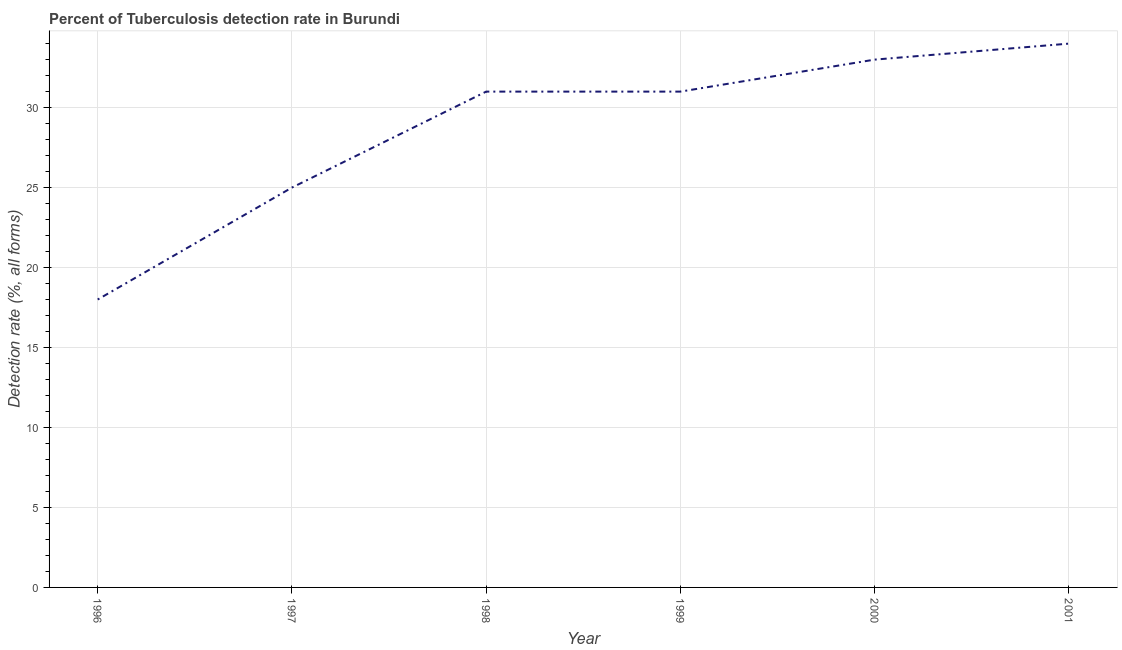What is the detection rate of tuberculosis in 2000?
Your answer should be compact. 33. Across all years, what is the maximum detection rate of tuberculosis?
Provide a succinct answer. 34. Across all years, what is the minimum detection rate of tuberculosis?
Provide a short and direct response. 18. In which year was the detection rate of tuberculosis maximum?
Provide a succinct answer. 2001. In which year was the detection rate of tuberculosis minimum?
Ensure brevity in your answer.  1996. What is the sum of the detection rate of tuberculosis?
Your answer should be compact. 172. What is the difference between the detection rate of tuberculosis in 1999 and 2001?
Your response must be concise. -3. What is the average detection rate of tuberculosis per year?
Provide a short and direct response. 28.67. What is the median detection rate of tuberculosis?
Your answer should be compact. 31. What is the ratio of the detection rate of tuberculosis in 1996 to that in 1997?
Ensure brevity in your answer.  0.72. Is the detection rate of tuberculosis in 1998 less than that in 2000?
Make the answer very short. Yes. What is the difference between the highest and the second highest detection rate of tuberculosis?
Ensure brevity in your answer.  1. Is the sum of the detection rate of tuberculosis in 1997 and 1998 greater than the maximum detection rate of tuberculosis across all years?
Make the answer very short. Yes. What is the difference between the highest and the lowest detection rate of tuberculosis?
Provide a succinct answer. 16. How many lines are there?
Ensure brevity in your answer.  1. What is the difference between two consecutive major ticks on the Y-axis?
Give a very brief answer. 5. Does the graph contain any zero values?
Your answer should be compact. No. Does the graph contain grids?
Your answer should be compact. Yes. What is the title of the graph?
Ensure brevity in your answer.  Percent of Tuberculosis detection rate in Burundi. What is the label or title of the Y-axis?
Provide a succinct answer. Detection rate (%, all forms). What is the Detection rate (%, all forms) in 1997?
Offer a very short reply. 25. What is the Detection rate (%, all forms) in 2000?
Ensure brevity in your answer.  33. What is the Detection rate (%, all forms) of 2001?
Offer a very short reply. 34. What is the difference between the Detection rate (%, all forms) in 1996 and 1999?
Keep it short and to the point. -13. What is the difference between the Detection rate (%, all forms) in 1998 and 1999?
Your answer should be compact. 0. What is the difference between the Detection rate (%, all forms) in 1998 and 2000?
Ensure brevity in your answer.  -2. What is the ratio of the Detection rate (%, all forms) in 1996 to that in 1997?
Your answer should be very brief. 0.72. What is the ratio of the Detection rate (%, all forms) in 1996 to that in 1998?
Keep it short and to the point. 0.58. What is the ratio of the Detection rate (%, all forms) in 1996 to that in 1999?
Give a very brief answer. 0.58. What is the ratio of the Detection rate (%, all forms) in 1996 to that in 2000?
Provide a short and direct response. 0.55. What is the ratio of the Detection rate (%, all forms) in 1996 to that in 2001?
Give a very brief answer. 0.53. What is the ratio of the Detection rate (%, all forms) in 1997 to that in 1998?
Provide a short and direct response. 0.81. What is the ratio of the Detection rate (%, all forms) in 1997 to that in 1999?
Keep it short and to the point. 0.81. What is the ratio of the Detection rate (%, all forms) in 1997 to that in 2000?
Your answer should be compact. 0.76. What is the ratio of the Detection rate (%, all forms) in 1997 to that in 2001?
Make the answer very short. 0.73. What is the ratio of the Detection rate (%, all forms) in 1998 to that in 1999?
Provide a succinct answer. 1. What is the ratio of the Detection rate (%, all forms) in 1998 to that in 2000?
Make the answer very short. 0.94. What is the ratio of the Detection rate (%, all forms) in 1998 to that in 2001?
Your response must be concise. 0.91. What is the ratio of the Detection rate (%, all forms) in 1999 to that in 2000?
Provide a succinct answer. 0.94. What is the ratio of the Detection rate (%, all forms) in 1999 to that in 2001?
Your answer should be very brief. 0.91. What is the ratio of the Detection rate (%, all forms) in 2000 to that in 2001?
Provide a succinct answer. 0.97. 